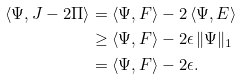<formula> <loc_0><loc_0><loc_500><loc_500>\langle \Psi , J - 2 \Pi \rangle & = \langle \Psi , F \rangle - 2 \, \langle \Psi , E \rangle \\ & \geq \langle \Psi , F \rangle - 2 \epsilon \, \| \Psi \| _ { 1 } \\ & = \langle \Psi , F \rangle - 2 \epsilon .</formula> 